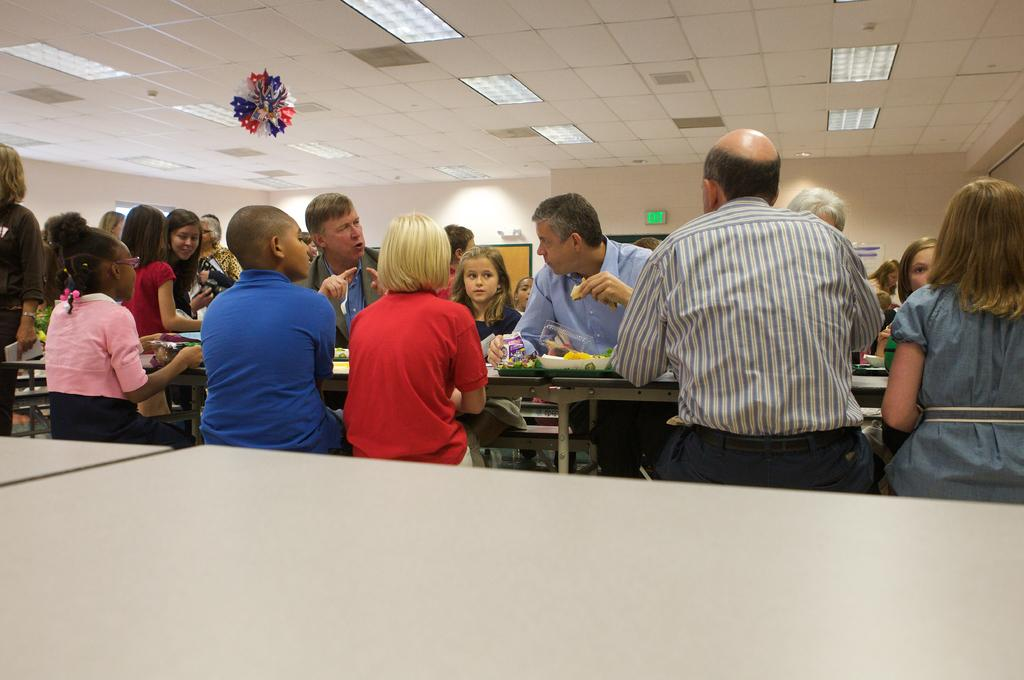What are the people in the image doing? There are people sitting on a bench and standing in the image. What can be seen in the background of the image? There is a board in the image. What type of objects can be seen in the image? Decorative objects are present in the image. What can be used for illumination in the image? Lights are visible in the image. What type of farm animals can be seen in the image? There are no farm animals present in the image. What type of feast is being prepared in the image? There is no feast being prepared in the image. 